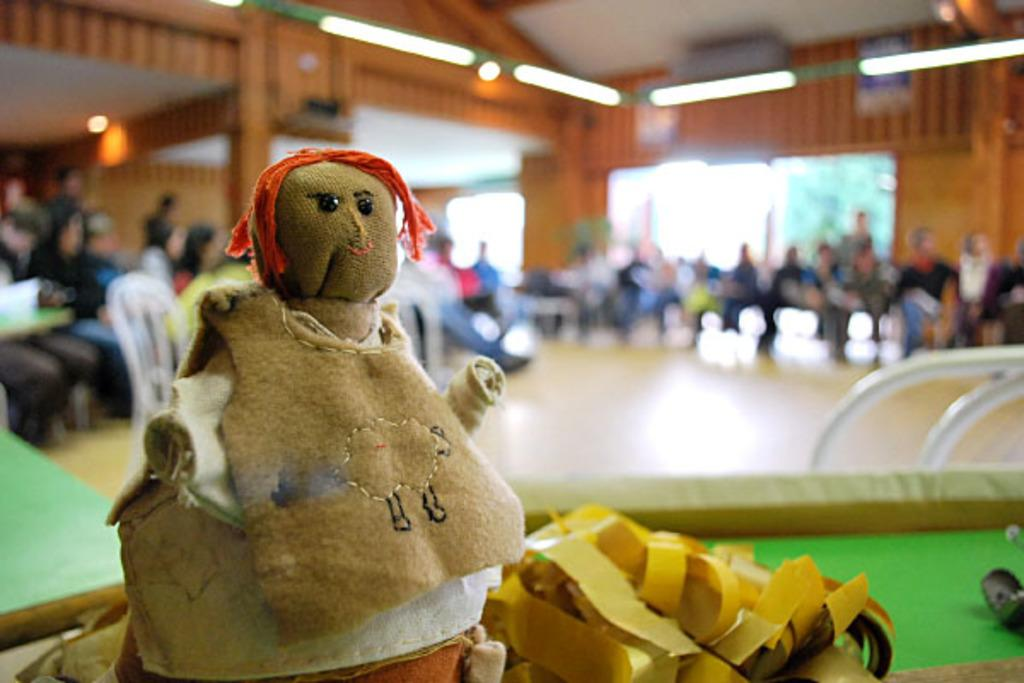What is the main object in the foreground of the image? There is a toy in the foreground of the image. What are the people in the image doing? The group of people are sitting on chairs in the background of the image. What can be seen at the top of the image? There are lights visible at the top of the image. Where is the tree located in the image? The tree is behind a door in the image. How many rabbits are hopping around the flag in the image? There are no rabbits or flags present in the image. 